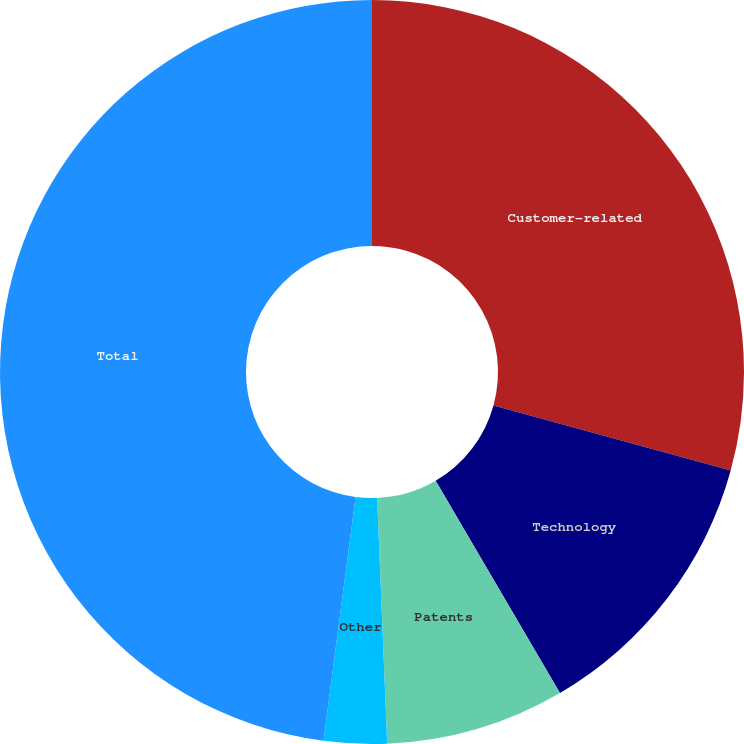<chart> <loc_0><loc_0><loc_500><loc_500><pie_chart><fcel>Customer-related<fcel>Technology<fcel>Patents<fcel>Other<fcel>Total<nl><fcel>29.27%<fcel>12.3%<fcel>7.78%<fcel>2.73%<fcel>47.92%<nl></chart> 